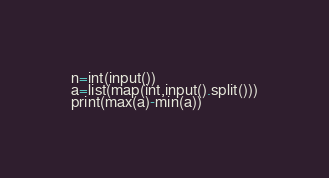Convert code to text. <code><loc_0><loc_0><loc_500><loc_500><_Python_>n=int(input())
a=list(map(int,input().split()))
print(max(a)-min(a))</code> 